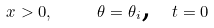<formula> <loc_0><loc_0><loc_500><loc_500>x > 0 , \text { \quad } \theta = \theta _ { i } \text {, \ } t = 0</formula> 